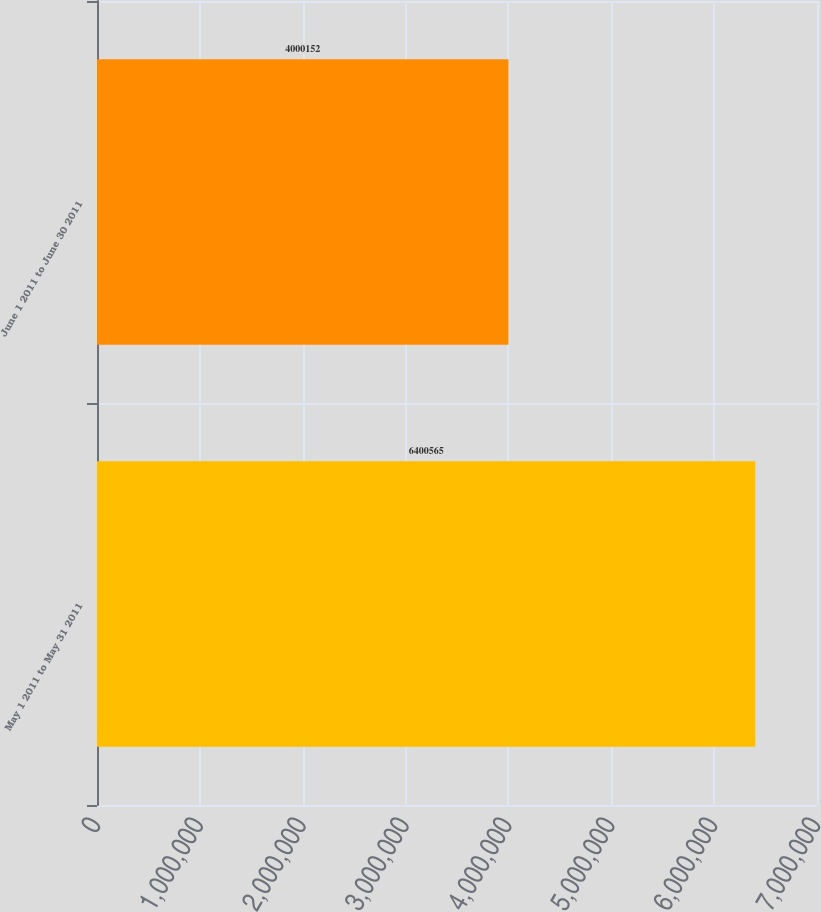<chart> <loc_0><loc_0><loc_500><loc_500><bar_chart><fcel>May 1 2011 to May 31 2011<fcel>June 1 2011 to June 30 2011<nl><fcel>6.40056e+06<fcel>4.00015e+06<nl></chart> 